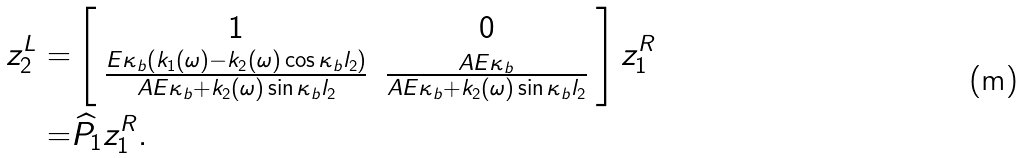<formula> <loc_0><loc_0><loc_500><loc_500>z _ { 2 } ^ { L } = & \left [ \begin{array} { c c } 1 & 0 \\ \frac { E \kappa _ { b } \left ( k _ { 1 } ( \omega ) - k _ { 2 } ( \omega ) \cos \kappa _ { b } l _ { 2 } \right ) } { A E \kappa _ { b } + k _ { 2 } ( \omega ) \sin \kappa _ { b } l _ { 2 } } & \frac { A E \kappa _ { b } } { A E \kappa _ { b } + k _ { 2 } ( \omega ) \sin \kappa _ { b } l _ { 2 } } \end{array} \right ] z _ { 1 } ^ { R } \\ = & \widehat { P } _ { 1 } z _ { 1 } ^ { R } .</formula> 